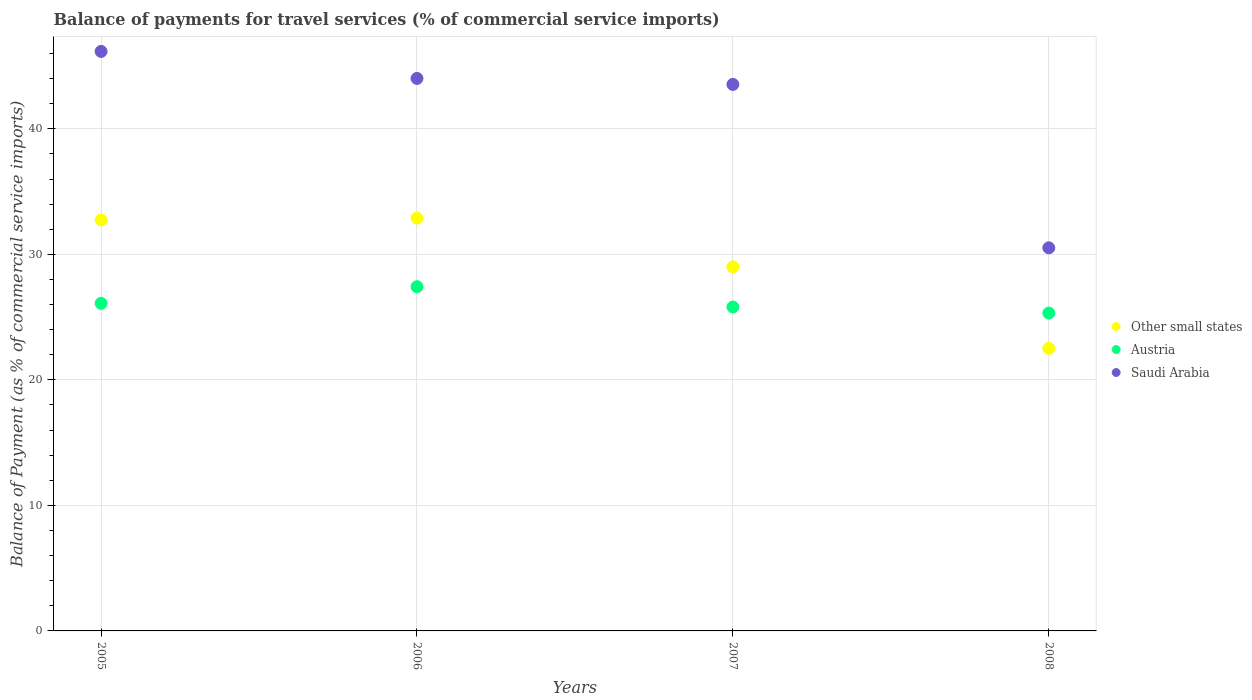How many different coloured dotlines are there?
Keep it short and to the point. 3. Is the number of dotlines equal to the number of legend labels?
Offer a terse response. Yes. What is the balance of payments for travel services in Austria in 2006?
Provide a succinct answer. 27.42. Across all years, what is the maximum balance of payments for travel services in Other small states?
Your answer should be very brief. 32.89. Across all years, what is the minimum balance of payments for travel services in Other small states?
Keep it short and to the point. 22.51. What is the total balance of payments for travel services in Other small states in the graph?
Provide a succinct answer. 117.13. What is the difference between the balance of payments for travel services in Other small states in 2006 and that in 2008?
Offer a terse response. 10.38. What is the difference between the balance of payments for travel services in Austria in 2006 and the balance of payments for travel services in Other small states in 2005?
Your response must be concise. -5.32. What is the average balance of payments for travel services in Saudi Arabia per year?
Your answer should be compact. 41.06. In the year 2005, what is the difference between the balance of payments for travel services in Saudi Arabia and balance of payments for travel services in Other small states?
Ensure brevity in your answer.  13.42. What is the ratio of the balance of payments for travel services in Other small states in 2005 to that in 2007?
Keep it short and to the point. 1.13. Is the difference between the balance of payments for travel services in Saudi Arabia in 2006 and 2008 greater than the difference between the balance of payments for travel services in Other small states in 2006 and 2008?
Keep it short and to the point. Yes. What is the difference between the highest and the second highest balance of payments for travel services in Other small states?
Your answer should be very brief. 0.14. What is the difference between the highest and the lowest balance of payments for travel services in Saudi Arabia?
Your answer should be compact. 15.65. In how many years, is the balance of payments for travel services in Saudi Arabia greater than the average balance of payments for travel services in Saudi Arabia taken over all years?
Keep it short and to the point. 3. What is the difference between two consecutive major ticks on the Y-axis?
Offer a terse response. 10. Does the graph contain any zero values?
Provide a short and direct response. No. Does the graph contain grids?
Offer a very short reply. Yes. Where does the legend appear in the graph?
Keep it short and to the point. Center right. What is the title of the graph?
Offer a terse response. Balance of payments for travel services (% of commercial service imports). Does "Kenya" appear as one of the legend labels in the graph?
Ensure brevity in your answer.  No. What is the label or title of the Y-axis?
Provide a succinct answer. Balance of Payment (as % of commercial service imports). What is the Balance of Payment (as % of commercial service imports) of Other small states in 2005?
Offer a very short reply. 32.74. What is the Balance of Payment (as % of commercial service imports) of Austria in 2005?
Your response must be concise. 26.1. What is the Balance of Payment (as % of commercial service imports) of Saudi Arabia in 2005?
Keep it short and to the point. 46.16. What is the Balance of Payment (as % of commercial service imports) in Other small states in 2006?
Provide a succinct answer. 32.89. What is the Balance of Payment (as % of commercial service imports) in Austria in 2006?
Offer a terse response. 27.42. What is the Balance of Payment (as % of commercial service imports) of Saudi Arabia in 2006?
Ensure brevity in your answer.  44.01. What is the Balance of Payment (as % of commercial service imports) of Other small states in 2007?
Your answer should be compact. 28.99. What is the Balance of Payment (as % of commercial service imports) in Austria in 2007?
Ensure brevity in your answer.  25.8. What is the Balance of Payment (as % of commercial service imports) of Saudi Arabia in 2007?
Offer a very short reply. 43.53. What is the Balance of Payment (as % of commercial service imports) of Other small states in 2008?
Your answer should be very brief. 22.51. What is the Balance of Payment (as % of commercial service imports) in Austria in 2008?
Provide a short and direct response. 25.32. What is the Balance of Payment (as % of commercial service imports) in Saudi Arabia in 2008?
Provide a succinct answer. 30.52. Across all years, what is the maximum Balance of Payment (as % of commercial service imports) of Other small states?
Give a very brief answer. 32.89. Across all years, what is the maximum Balance of Payment (as % of commercial service imports) in Austria?
Offer a very short reply. 27.42. Across all years, what is the maximum Balance of Payment (as % of commercial service imports) of Saudi Arabia?
Your answer should be very brief. 46.16. Across all years, what is the minimum Balance of Payment (as % of commercial service imports) in Other small states?
Your answer should be very brief. 22.51. Across all years, what is the minimum Balance of Payment (as % of commercial service imports) of Austria?
Offer a terse response. 25.32. Across all years, what is the minimum Balance of Payment (as % of commercial service imports) of Saudi Arabia?
Ensure brevity in your answer.  30.52. What is the total Balance of Payment (as % of commercial service imports) in Other small states in the graph?
Your answer should be very brief. 117.13. What is the total Balance of Payment (as % of commercial service imports) of Austria in the graph?
Provide a succinct answer. 104.64. What is the total Balance of Payment (as % of commercial service imports) of Saudi Arabia in the graph?
Your answer should be compact. 164.23. What is the difference between the Balance of Payment (as % of commercial service imports) in Other small states in 2005 and that in 2006?
Your answer should be very brief. -0.14. What is the difference between the Balance of Payment (as % of commercial service imports) in Austria in 2005 and that in 2006?
Offer a terse response. -1.33. What is the difference between the Balance of Payment (as % of commercial service imports) of Saudi Arabia in 2005 and that in 2006?
Keep it short and to the point. 2.15. What is the difference between the Balance of Payment (as % of commercial service imports) in Other small states in 2005 and that in 2007?
Your answer should be compact. 3.75. What is the difference between the Balance of Payment (as % of commercial service imports) of Austria in 2005 and that in 2007?
Offer a terse response. 0.29. What is the difference between the Balance of Payment (as % of commercial service imports) in Saudi Arabia in 2005 and that in 2007?
Give a very brief answer. 2.63. What is the difference between the Balance of Payment (as % of commercial service imports) in Other small states in 2005 and that in 2008?
Make the answer very short. 10.23. What is the difference between the Balance of Payment (as % of commercial service imports) of Austria in 2005 and that in 2008?
Provide a succinct answer. 0.77. What is the difference between the Balance of Payment (as % of commercial service imports) of Saudi Arabia in 2005 and that in 2008?
Make the answer very short. 15.65. What is the difference between the Balance of Payment (as % of commercial service imports) of Other small states in 2006 and that in 2007?
Your answer should be compact. 3.89. What is the difference between the Balance of Payment (as % of commercial service imports) in Austria in 2006 and that in 2007?
Give a very brief answer. 1.62. What is the difference between the Balance of Payment (as % of commercial service imports) in Saudi Arabia in 2006 and that in 2007?
Offer a terse response. 0.48. What is the difference between the Balance of Payment (as % of commercial service imports) of Other small states in 2006 and that in 2008?
Offer a very short reply. 10.38. What is the difference between the Balance of Payment (as % of commercial service imports) in Austria in 2006 and that in 2008?
Your answer should be compact. 2.1. What is the difference between the Balance of Payment (as % of commercial service imports) in Saudi Arabia in 2006 and that in 2008?
Make the answer very short. 13.49. What is the difference between the Balance of Payment (as % of commercial service imports) of Other small states in 2007 and that in 2008?
Provide a short and direct response. 6.48. What is the difference between the Balance of Payment (as % of commercial service imports) of Austria in 2007 and that in 2008?
Your response must be concise. 0.48. What is the difference between the Balance of Payment (as % of commercial service imports) in Saudi Arabia in 2007 and that in 2008?
Provide a short and direct response. 13.02. What is the difference between the Balance of Payment (as % of commercial service imports) of Other small states in 2005 and the Balance of Payment (as % of commercial service imports) of Austria in 2006?
Give a very brief answer. 5.32. What is the difference between the Balance of Payment (as % of commercial service imports) in Other small states in 2005 and the Balance of Payment (as % of commercial service imports) in Saudi Arabia in 2006?
Your answer should be compact. -11.27. What is the difference between the Balance of Payment (as % of commercial service imports) in Austria in 2005 and the Balance of Payment (as % of commercial service imports) in Saudi Arabia in 2006?
Ensure brevity in your answer.  -17.92. What is the difference between the Balance of Payment (as % of commercial service imports) in Other small states in 2005 and the Balance of Payment (as % of commercial service imports) in Austria in 2007?
Provide a short and direct response. 6.94. What is the difference between the Balance of Payment (as % of commercial service imports) of Other small states in 2005 and the Balance of Payment (as % of commercial service imports) of Saudi Arabia in 2007?
Your answer should be compact. -10.79. What is the difference between the Balance of Payment (as % of commercial service imports) of Austria in 2005 and the Balance of Payment (as % of commercial service imports) of Saudi Arabia in 2007?
Your answer should be very brief. -17.44. What is the difference between the Balance of Payment (as % of commercial service imports) in Other small states in 2005 and the Balance of Payment (as % of commercial service imports) in Austria in 2008?
Offer a terse response. 7.42. What is the difference between the Balance of Payment (as % of commercial service imports) of Other small states in 2005 and the Balance of Payment (as % of commercial service imports) of Saudi Arabia in 2008?
Keep it short and to the point. 2.22. What is the difference between the Balance of Payment (as % of commercial service imports) of Austria in 2005 and the Balance of Payment (as % of commercial service imports) of Saudi Arabia in 2008?
Offer a very short reply. -4.42. What is the difference between the Balance of Payment (as % of commercial service imports) of Other small states in 2006 and the Balance of Payment (as % of commercial service imports) of Austria in 2007?
Your answer should be compact. 7.08. What is the difference between the Balance of Payment (as % of commercial service imports) of Other small states in 2006 and the Balance of Payment (as % of commercial service imports) of Saudi Arabia in 2007?
Give a very brief answer. -10.65. What is the difference between the Balance of Payment (as % of commercial service imports) in Austria in 2006 and the Balance of Payment (as % of commercial service imports) in Saudi Arabia in 2007?
Offer a terse response. -16.11. What is the difference between the Balance of Payment (as % of commercial service imports) in Other small states in 2006 and the Balance of Payment (as % of commercial service imports) in Austria in 2008?
Your answer should be compact. 7.56. What is the difference between the Balance of Payment (as % of commercial service imports) in Other small states in 2006 and the Balance of Payment (as % of commercial service imports) in Saudi Arabia in 2008?
Offer a terse response. 2.37. What is the difference between the Balance of Payment (as % of commercial service imports) of Austria in 2006 and the Balance of Payment (as % of commercial service imports) of Saudi Arabia in 2008?
Give a very brief answer. -3.1. What is the difference between the Balance of Payment (as % of commercial service imports) of Other small states in 2007 and the Balance of Payment (as % of commercial service imports) of Austria in 2008?
Give a very brief answer. 3.67. What is the difference between the Balance of Payment (as % of commercial service imports) in Other small states in 2007 and the Balance of Payment (as % of commercial service imports) in Saudi Arabia in 2008?
Make the answer very short. -1.53. What is the difference between the Balance of Payment (as % of commercial service imports) in Austria in 2007 and the Balance of Payment (as % of commercial service imports) in Saudi Arabia in 2008?
Your response must be concise. -4.72. What is the average Balance of Payment (as % of commercial service imports) of Other small states per year?
Your answer should be very brief. 29.28. What is the average Balance of Payment (as % of commercial service imports) in Austria per year?
Offer a terse response. 26.16. What is the average Balance of Payment (as % of commercial service imports) of Saudi Arabia per year?
Your response must be concise. 41.06. In the year 2005, what is the difference between the Balance of Payment (as % of commercial service imports) of Other small states and Balance of Payment (as % of commercial service imports) of Austria?
Give a very brief answer. 6.65. In the year 2005, what is the difference between the Balance of Payment (as % of commercial service imports) of Other small states and Balance of Payment (as % of commercial service imports) of Saudi Arabia?
Your answer should be very brief. -13.42. In the year 2005, what is the difference between the Balance of Payment (as % of commercial service imports) in Austria and Balance of Payment (as % of commercial service imports) in Saudi Arabia?
Ensure brevity in your answer.  -20.07. In the year 2006, what is the difference between the Balance of Payment (as % of commercial service imports) in Other small states and Balance of Payment (as % of commercial service imports) in Austria?
Your answer should be compact. 5.46. In the year 2006, what is the difference between the Balance of Payment (as % of commercial service imports) of Other small states and Balance of Payment (as % of commercial service imports) of Saudi Arabia?
Offer a very short reply. -11.13. In the year 2006, what is the difference between the Balance of Payment (as % of commercial service imports) in Austria and Balance of Payment (as % of commercial service imports) in Saudi Arabia?
Offer a terse response. -16.59. In the year 2007, what is the difference between the Balance of Payment (as % of commercial service imports) in Other small states and Balance of Payment (as % of commercial service imports) in Austria?
Your answer should be very brief. 3.19. In the year 2007, what is the difference between the Balance of Payment (as % of commercial service imports) of Other small states and Balance of Payment (as % of commercial service imports) of Saudi Arabia?
Keep it short and to the point. -14.54. In the year 2007, what is the difference between the Balance of Payment (as % of commercial service imports) of Austria and Balance of Payment (as % of commercial service imports) of Saudi Arabia?
Provide a succinct answer. -17.73. In the year 2008, what is the difference between the Balance of Payment (as % of commercial service imports) in Other small states and Balance of Payment (as % of commercial service imports) in Austria?
Keep it short and to the point. -2.81. In the year 2008, what is the difference between the Balance of Payment (as % of commercial service imports) in Other small states and Balance of Payment (as % of commercial service imports) in Saudi Arabia?
Offer a terse response. -8.01. In the year 2008, what is the difference between the Balance of Payment (as % of commercial service imports) of Austria and Balance of Payment (as % of commercial service imports) of Saudi Arabia?
Keep it short and to the point. -5.2. What is the ratio of the Balance of Payment (as % of commercial service imports) in Other small states in 2005 to that in 2006?
Your answer should be compact. 1. What is the ratio of the Balance of Payment (as % of commercial service imports) in Austria in 2005 to that in 2006?
Ensure brevity in your answer.  0.95. What is the ratio of the Balance of Payment (as % of commercial service imports) in Saudi Arabia in 2005 to that in 2006?
Provide a succinct answer. 1.05. What is the ratio of the Balance of Payment (as % of commercial service imports) in Other small states in 2005 to that in 2007?
Provide a short and direct response. 1.13. What is the ratio of the Balance of Payment (as % of commercial service imports) in Austria in 2005 to that in 2007?
Provide a succinct answer. 1.01. What is the ratio of the Balance of Payment (as % of commercial service imports) in Saudi Arabia in 2005 to that in 2007?
Make the answer very short. 1.06. What is the ratio of the Balance of Payment (as % of commercial service imports) of Other small states in 2005 to that in 2008?
Ensure brevity in your answer.  1.45. What is the ratio of the Balance of Payment (as % of commercial service imports) of Austria in 2005 to that in 2008?
Keep it short and to the point. 1.03. What is the ratio of the Balance of Payment (as % of commercial service imports) of Saudi Arabia in 2005 to that in 2008?
Offer a terse response. 1.51. What is the ratio of the Balance of Payment (as % of commercial service imports) in Other small states in 2006 to that in 2007?
Ensure brevity in your answer.  1.13. What is the ratio of the Balance of Payment (as % of commercial service imports) of Austria in 2006 to that in 2007?
Your answer should be very brief. 1.06. What is the ratio of the Balance of Payment (as % of commercial service imports) in Other small states in 2006 to that in 2008?
Provide a short and direct response. 1.46. What is the ratio of the Balance of Payment (as % of commercial service imports) of Austria in 2006 to that in 2008?
Your answer should be compact. 1.08. What is the ratio of the Balance of Payment (as % of commercial service imports) in Saudi Arabia in 2006 to that in 2008?
Offer a very short reply. 1.44. What is the ratio of the Balance of Payment (as % of commercial service imports) of Other small states in 2007 to that in 2008?
Make the answer very short. 1.29. What is the ratio of the Balance of Payment (as % of commercial service imports) of Austria in 2007 to that in 2008?
Your answer should be compact. 1.02. What is the ratio of the Balance of Payment (as % of commercial service imports) in Saudi Arabia in 2007 to that in 2008?
Your answer should be very brief. 1.43. What is the difference between the highest and the second highest Balance of Payment (as % of commercial service imports) of Other small states?
Offer a terse response. 0.14. What is the difference between the highest and the second highest Balance of Payment (as % of commercial service imports) of Austria?
Give a very brief answer. 1.33. What is the difference between the highest and the second highest Balance of Payment (as % of commercial service imports) in Saudi Arabia?
Offer a very short reply. 2.15. What is the difference between the highest and the lowest Balance of Payment (as % of commercial service imports) of Other small states?
Your response must be concise. 10.38. What is the difference between the highest and the lowest Balance of Payment (as % of commercial service imports) in Austria?
Your response must be concise. 2.1. What is the difference between the highest and the lowest Balance of Payment (as % of commercial service imports) of Saudi Arabia?
Provide a succinct answer. 15.65. 